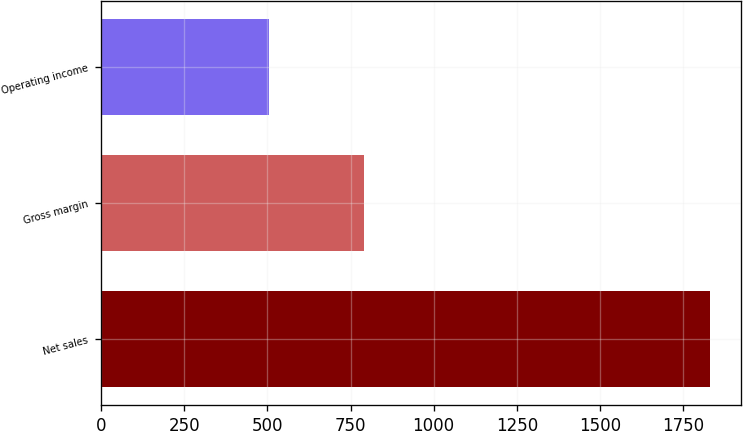Convert chart. <chart><loc_0><loc_0><loc_500><loc_500><bar_chart><fcel>Net sales<fcel>Gross margin<fcel>Operating income<nl><fcel>1832.3<fcel>791.3<fcel>504<nl></chart> 